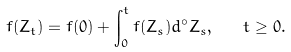Convert formula to latex. <formula><loc_0><loc_0><loc_500><loc_500>f ( Z _ { t } ) = f ( 0 ) + \int _ { 0 } ^ { t } f ( Z _ { s } ) d ^ { \circ } Z _ { s } , \quad t \geq 0 .</formula> 